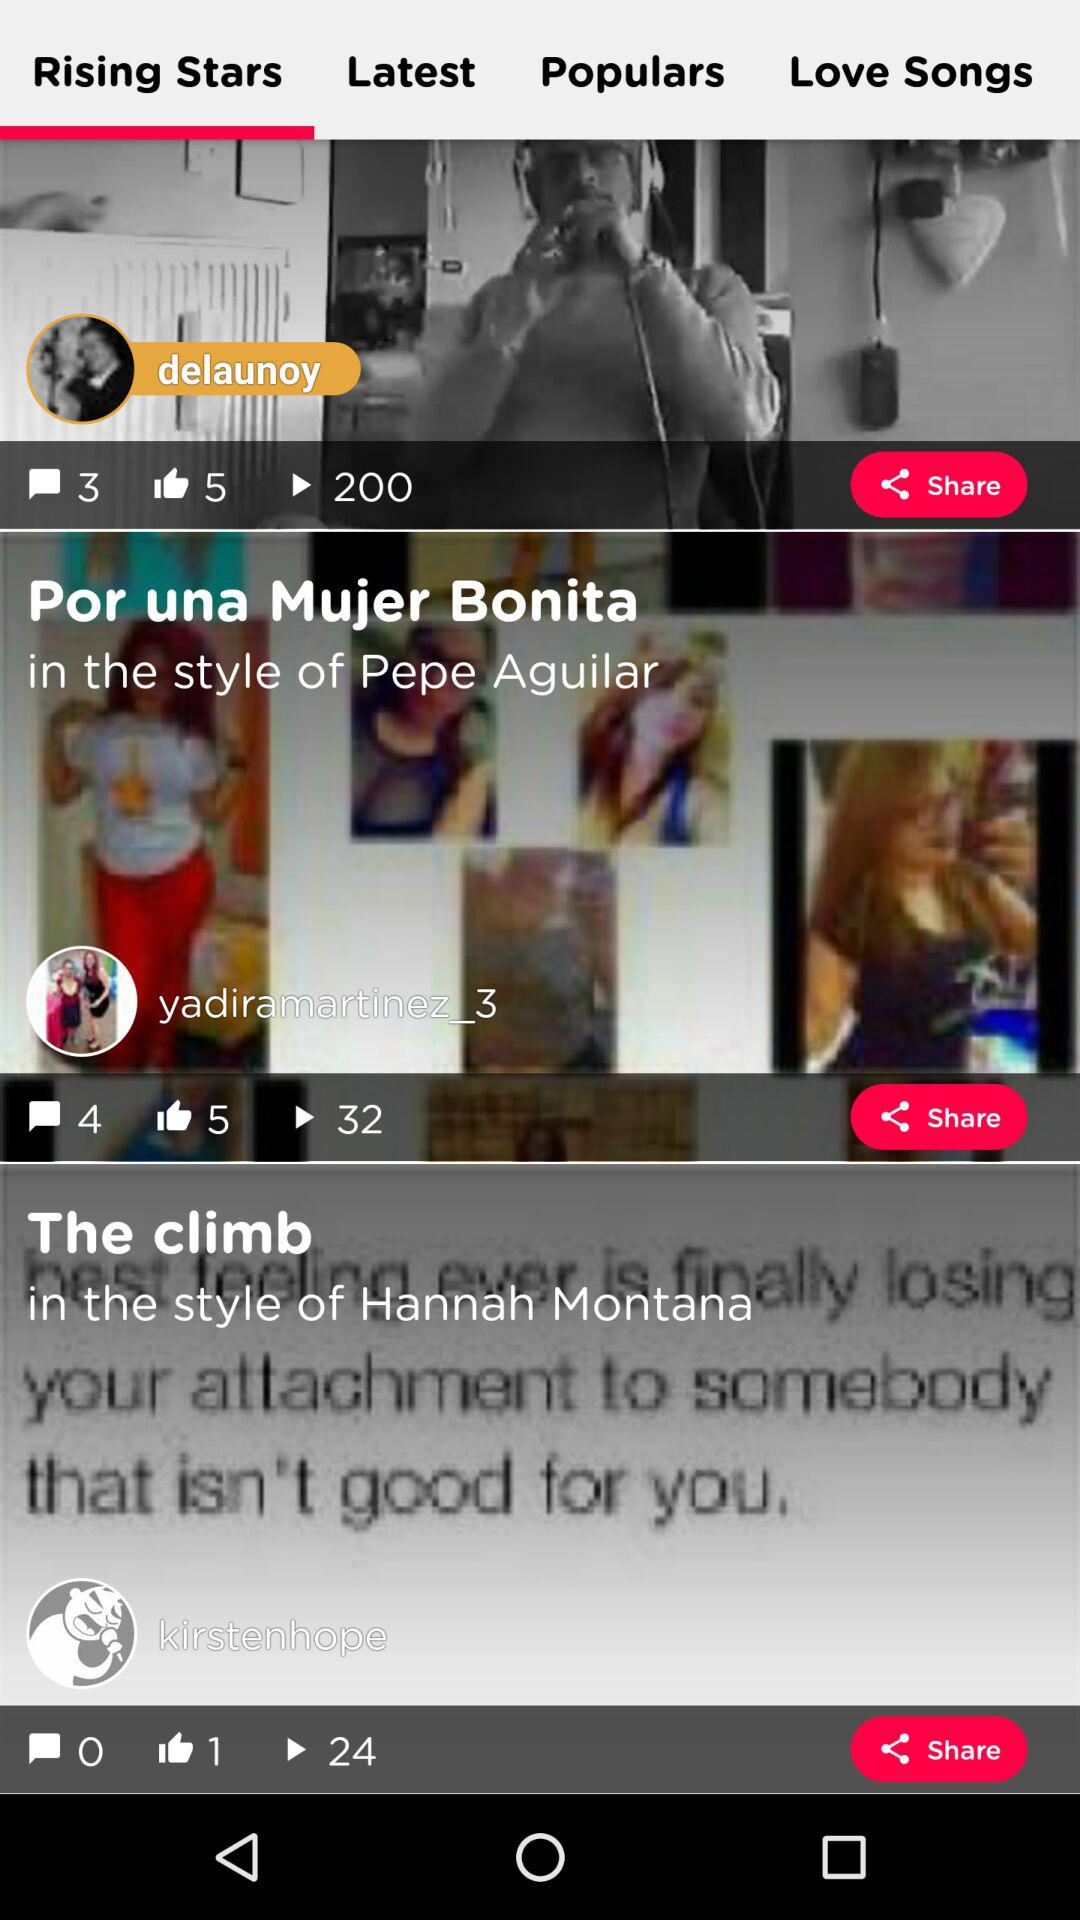How many likes are there on "The climb" post? There is one like. 